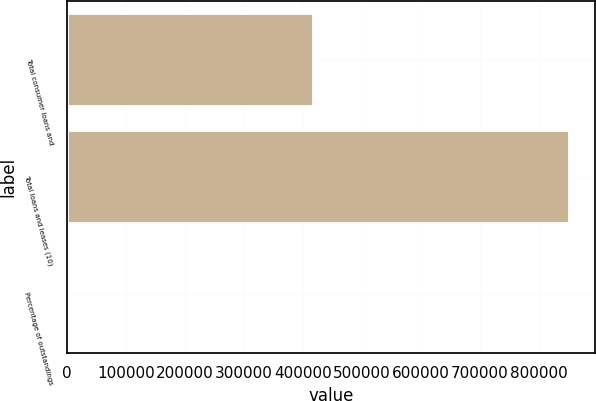<chart> <loc_0><loc_0><loc_500><loc_500><bar_chart><fcel>Total consumer loans and<fcel>Total loans and leases (10)<fcel>Percentage of outstandings<nl><fcel>418338<fcel>852629<fcel>95.06<nl></chart> 